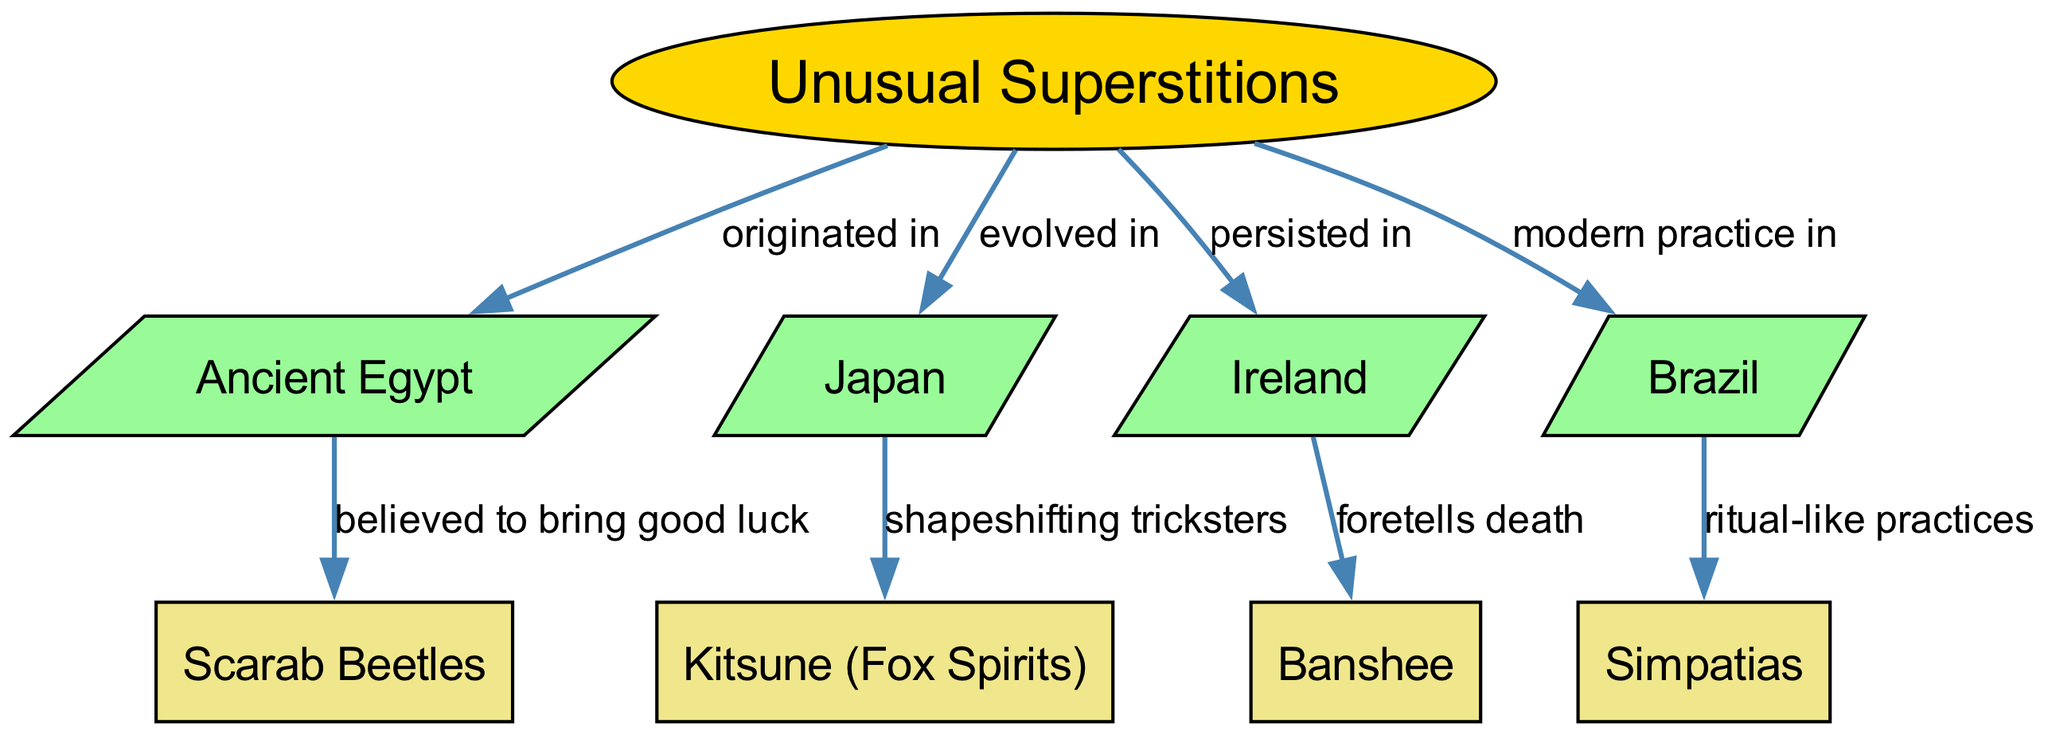What cultures are mentioned in the diagram regarding unusual superstitions? The diagram lists four cultures: Ancient Egypt, Japan, Ireland, and Brazil. These are the nodes directly connected to the main concept of unusual superstitions.
Answer: Ancient Egypt, Japan, Ireland, Brazil What does the scarab beetle symbolize in Ancient Egypt? The diagram states that scarab beetles were believed to bring good luck, as highlighted by the connection from Ancient Egypt to scarab beetles.
Answer: Good luck What does the kitsune represent in Japanese culture? From the diagram, kitsune are described as shapeshifting tricksters, which shows their significance in Japanese superstitions.
Answer: Shapeshifting tricksters What is the relationship between Ireland and the banshee in the context of superstitions? The diagram indicates that the banshee in Ireland foretells death, which directly connects these two nodes, demonstrating their cultural significance.
Answer: Foretells death How many edges are present in the diagram? There are a total of eight edges, which can be counted by observing the connections between the nodes in the diagram.
Answer: Eight Which culture practices simpatias as part of their superstitions? The diagram connects Brazil to simpatias, indicating that this modern practice is observed in Brazilian culture.
Answer: Brazil What type of practices are associated with simpatias in Brazil? The diagram describes simpatias as ritual-like practices, showing their nature in the context of Brazilian superstitions.
Answer: Ritual-like practices How did the concept of unusual superstitions evolve in Japan? According to the diagram, unusual superstitions evolved in Japan around the figure of the kitsune, which plays a significant role in their folklore.
Answer: Evolved with kitsune What cultural significance does the relationship between unusual superstitions and Ireland hold? The diagram reflects that unusual superstitions persisted in Ireland, with the banshee symbolizing a critical aspect of these beliefs.
Answer: Persisted in Ireland 